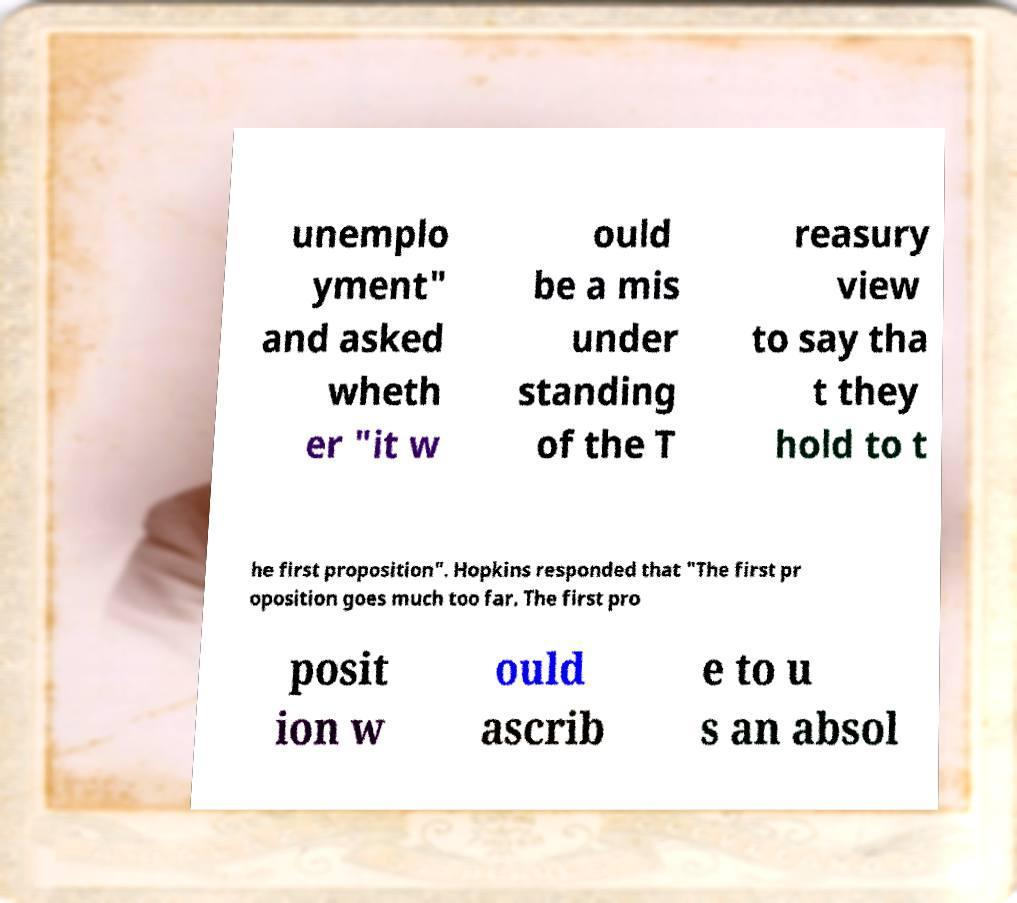Could you assist in decoding the text presented in this image and type it out clearly? unemplo yment" and asked wheth er "it w ould be a mis under standing of the T reasury view to say tha t they hold to t he first proposition". Hopkins responded that "The first pr oposition goes much too far. The first pro posit ion w ould ascrib e to u s an absol 